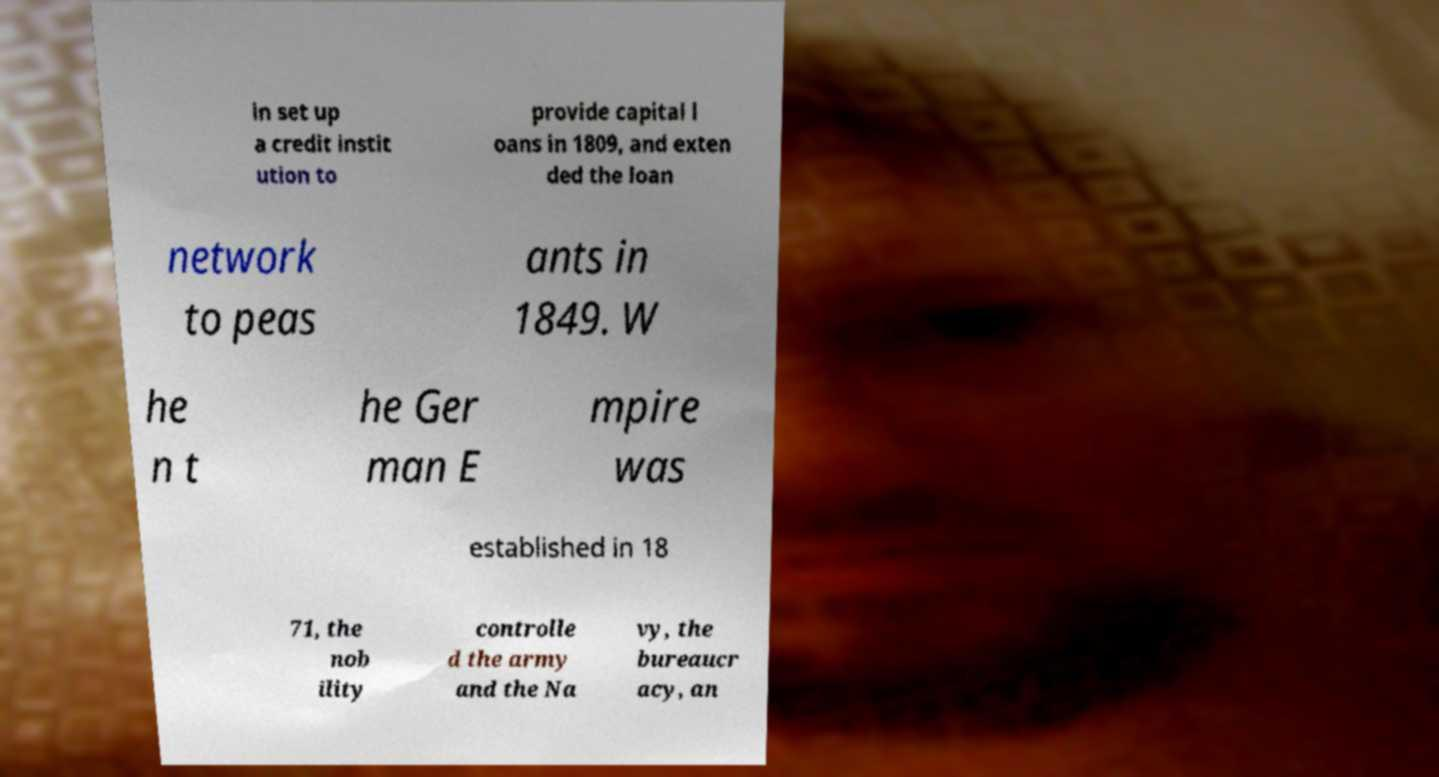For documentation purposes, I need the text within this image transcribed. Could you provide that? in set up a credit instit ution to provide capital l oans in 1809, and exten ded the loan network to peas ants in 1849. W he n t he Ger man E mpire was established in 18 71, the nob ility controlle d the army and the Na vy, the bureaucr acy, an 